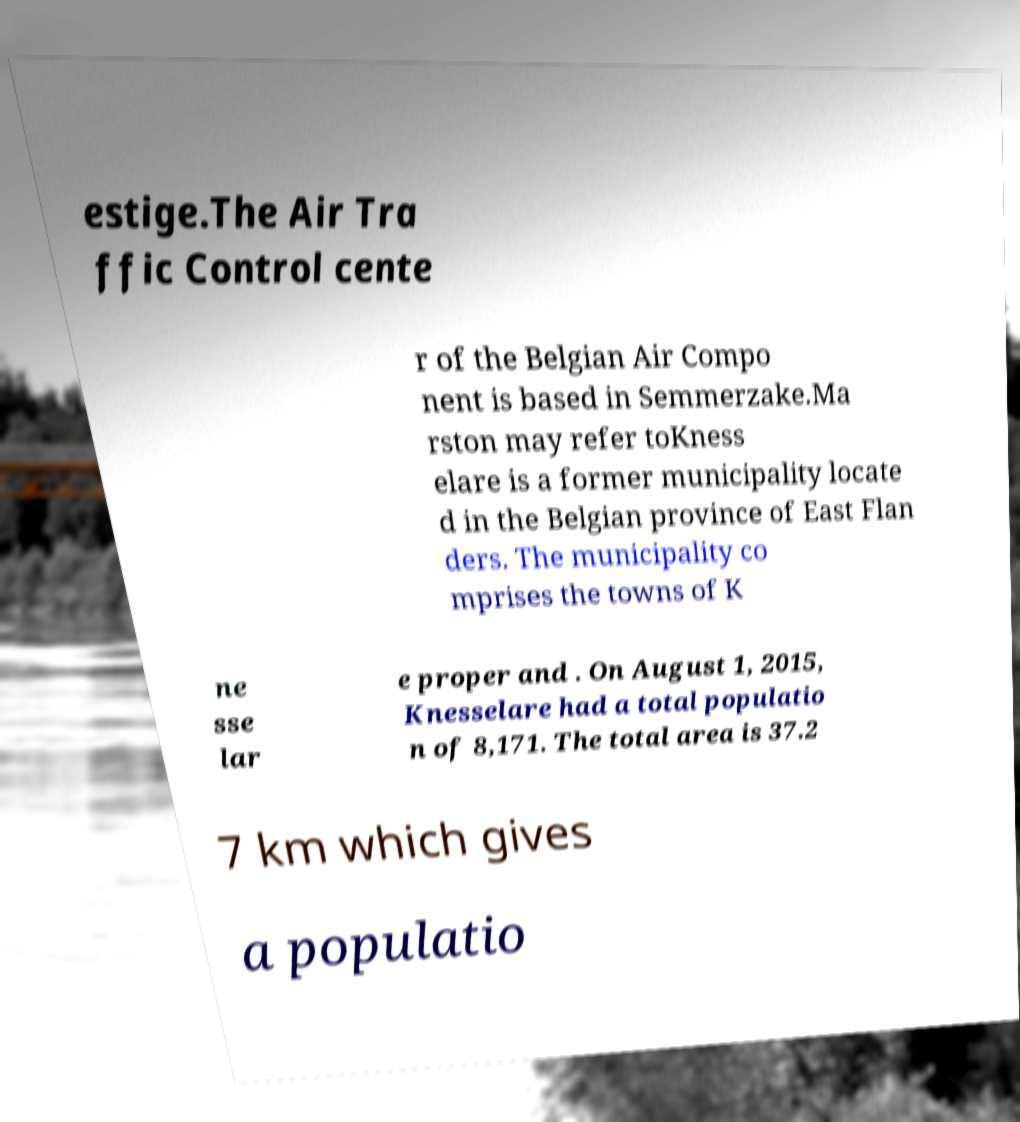There's text embedded in this image that I need extracted. Can you transcribe it verbatim? estige.The Air Tra ffic Control cente r of the Belgian Air Compo nent is based in Semmerzake.Ma rston may refer toKness elare is a former municipality locate d in the Belgian province of East Flan ders. The municipality co mprises the towns of K ne sse lar e proper and . On August 1, 2015, Knesselare had a total populatio n of 8,171. The total area is 37.2 7 km which gives a populatio 